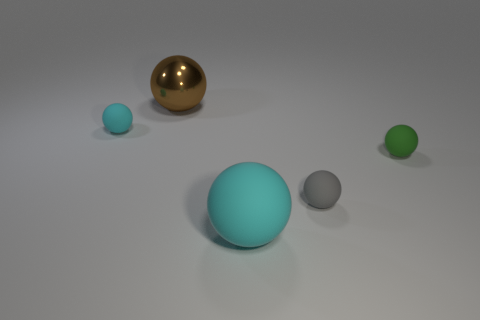There is a green thing that is the same shape as the gray matte thing; what is its size?
Provide a succinct answer. Small. There is a cyan matte sphere that is left of the cyan thing that is to the right of the large brown metallic thing; how many cyan objects are to the left of it?
Offer a terse response. 0. The small rubber sphere left of the large ball that is in front of the metallic object is what color?
Keep it short and to the point. Cyan. What number of other objects are there of the same material as the brown ball?
Provide a succinct answer. 0. There is a tiny green matte object that is in front of the tiny cyan ball; how many gray matte balls are in front of it?
Provide a short and direct response. 1. Is there any other thing that is the same shape as the big cyan rubber thing?
Provide a short and direct response. Yes. Does the big thing on the right side of the big brown shiny object have the same color as the object that is behind the tiny cyan sphere?
Provide a succinct answer. No. Is the number of big cyan rubber things less than the number of cyan rubber spheres?
Your answer should be compact. Yes. There is a tiny object on the left side of the cyan rubber object that is in front of the small green matte thing; what is its shape?
Your answer should be very brief. Sphere. Is there any other thing that is the same size as the brown metal sphere?
Give a very brief answer. Yes. 